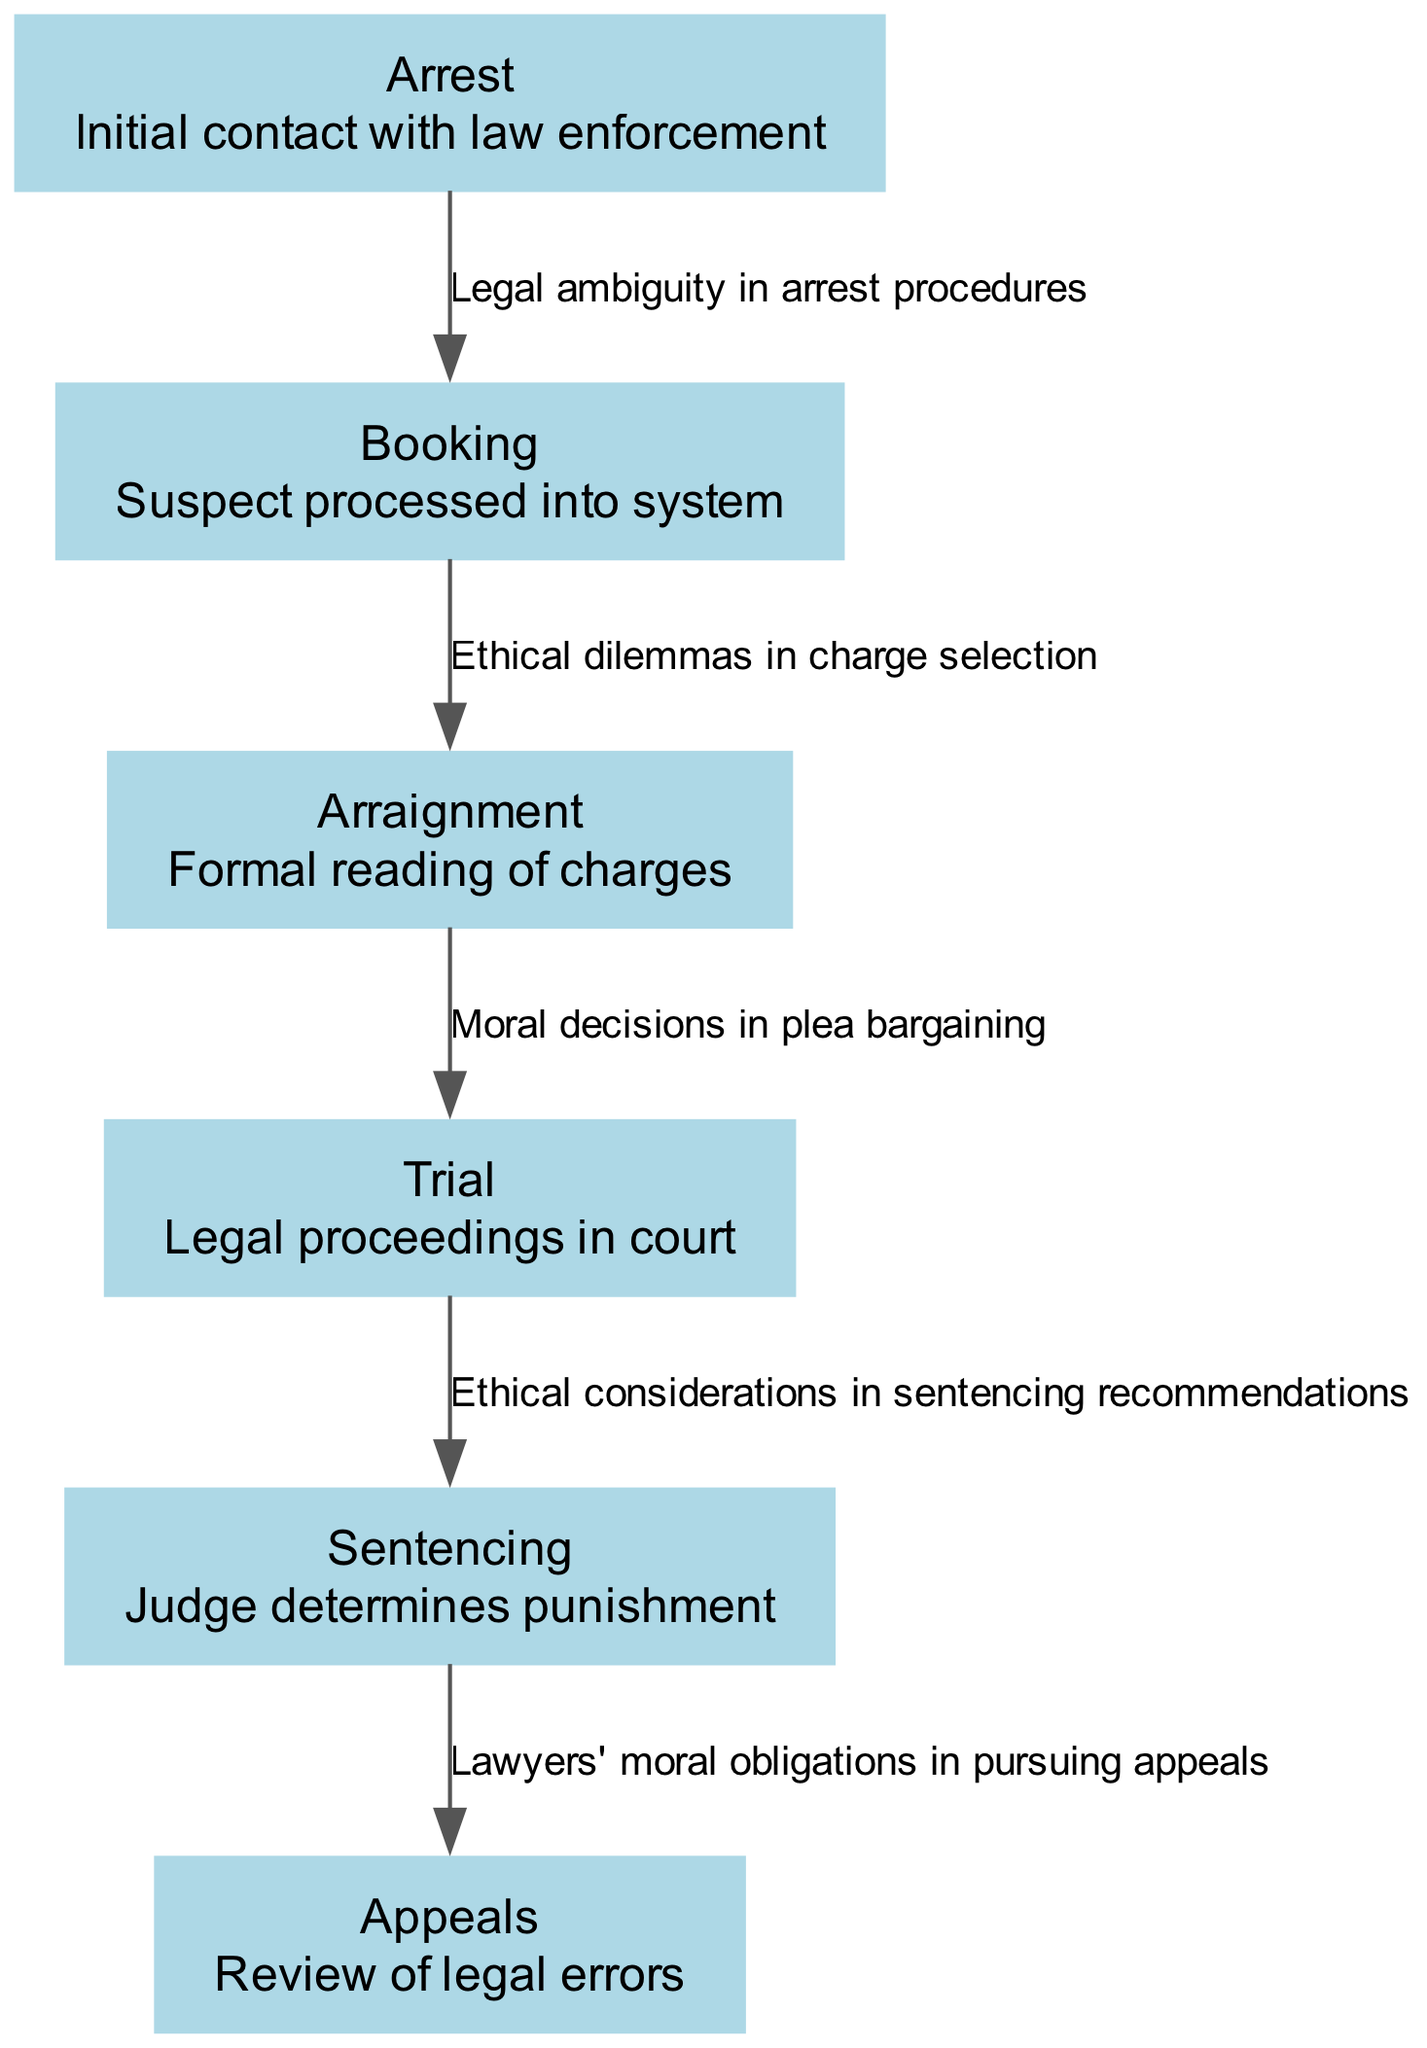What is the first step in the criminal justice food chain? The first node in the diagram is "Arrest," which represents the initial contact with law enforcement. This is indicated as the starting point of the food chain.
Answer: Arrest How many nodes are present in the diagram? The diagram features a total of six distinct nodes: Arrest, Booking, Arraignment, Trial, Sentencing, and Appeals. Counting these nodes gives us the total number.
Answer: Six What type of ethical dilemma is associated with the transition from Booking to Arraignment? The edge connecting Booking to Arraignment is labeled "Ethical dilemmas in charge selection," indicating the specific type of ethical dilemma involved at this stage.
Answer: Ethical dilemmas in charge selection What is the legal focus in the transition from Trial to Sentencing? The edge between Trial and Sentencing is labeled "Ethical considerations in sentencing recommendations," which indicates that the focus during this transition involves ethical considerations specific to how sentencing should be recommended.
Answer: Ethical considerations in sentencing recommendations What is the last step in the criminal justice food chain? The last node in the diagram is "Appeals," which represents the review of legal errors that occurs after sentencing, marking it as the concluding step in the process.
Answer: Appeals Which stage has a specific moral consideration in pursuing legal recourse? The edge from Sentencing to Appeals carries the label "Lawyers' moral obligations in pursuing appeals," indicating that this stage is where moral considerations are particularly emphasized.
Answer: Lawyers' moral obligations in pursuing appeals How many edges connect the nodes in the food chain? There are five edges in the diagram, each connecting different stages of the criminal justice process and depicting the relationships and transitions between them.
Answer: Five What is the primary legal concern when moving from Arraignment to Trial? The edge from Arraignment to Trial is labeled "Moral decisions in plea bargaining," highlighting the significant legal concern at this stage pertaining to plea negotiations.
Answer: Moral decisions in plea bargaining 